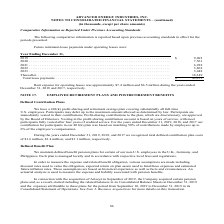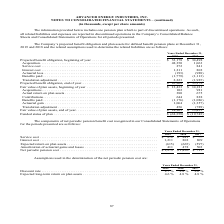According to Advanced Energy's financial document, Where does the company report all related liabilities and expenses to discontinued operations? in discontinued operations in the Company’s Consolidated Balance Sheets and Consolidated Statements of Operations for all periods presented.. The document states: "all related liabilities and expenses are reported in discontinued operations in the Company’s Consolidated Balance Sheets and Consolidated Statements ..." Also, What was the acquisition in 2019? According to the financial document, 48,350 (in thousands). The relevant text states: "ginning of year . $ 33,178 $ 34,498 Acquisition . 48,350 1,063 Service cost . 272 841 Interest cost . 1,211 802 Actuarial loss . (193) (988) Benefits paid ...." Also, What was the service cost in 2018? According to the financial document, 841 (in thousands). The relevant text states: "498 Acquisition . 48,350 1,063 Service cost . 272 841 Interest cost . 1,211 802 Actuarial loss . (193) (988) Benefits paid . (1,779) (1,113) Translation..." Also, can you calculate: What was the change in service cost between 2018 and 2019? Based on the calculation: 272-841, the result is -569 (in thousands). This is based on the information: "498 Acquisition . 48,350 1,063 Service cost . 272 841 Interest cost . 1,211 802 Actuarial loss . (193) (988) Benefits paid . (1,779) (1,113) Translation 34,498 Acquisition . 48,350 1,063 Service cost ..." The key data points involved are: 272, 841. Also, can you calculate: What was the change in interest cost between 2018 and 2019? Based on the calculation: 1,211-802, the result is 409 (in thousands). This is based on the information: ",350 1,063 Service cost . 272 841 Interest cost . 1,211 802 Actuarial loss . (193) (988) Benefits paid . (1,779) (1,113) Translation adjustment . 2,223 (1, ,063 Service cost . 272 841 Interest cost . ..." The key data points involved are: 1,211, 802. Also, can you calculate: What was the percentage change in the fair value of plan assets, end of the year between 2018 and 2019? To answer this question, I need to perform calculations using the financial data. The calculation is: ($14,903-$13,433)/$13,433, which equals 10.94 (percentage). This is based on the information: "Fair value of plan assets, beginning of year . $ 13,433 $ 14,181 Acquisitions . 102 981 Actual return on plan assets . 380 675 Contributions . 644 828 Bene (789) Fair value of plan assets, end of year..." The key data points involved are: 13,433, 14,903. 